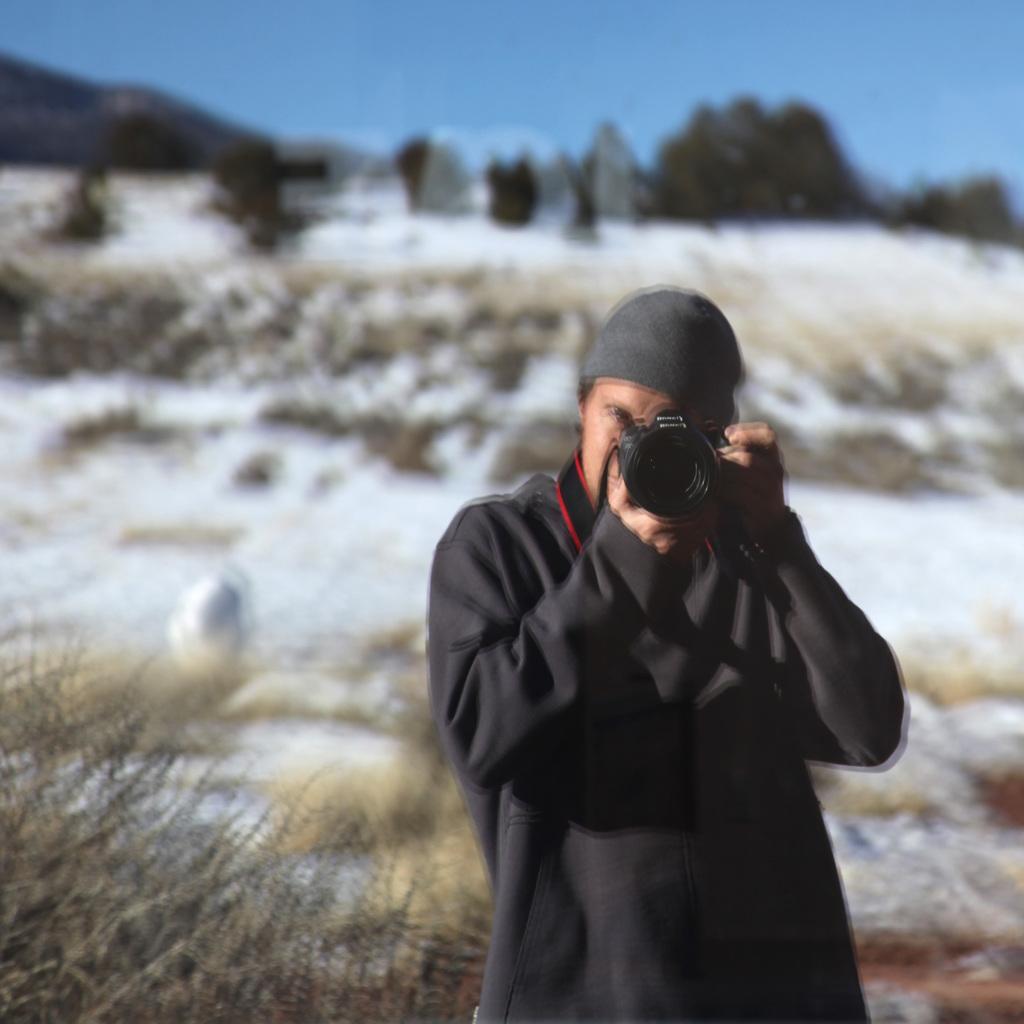Could you give a brief overview of what you see in this image? In this image I can see a person wearing a blue jacket is standing and holding a camera in his hand , i can see he is wearing a hat. In the background I can see few trees, snow, a mountain and the sky. 